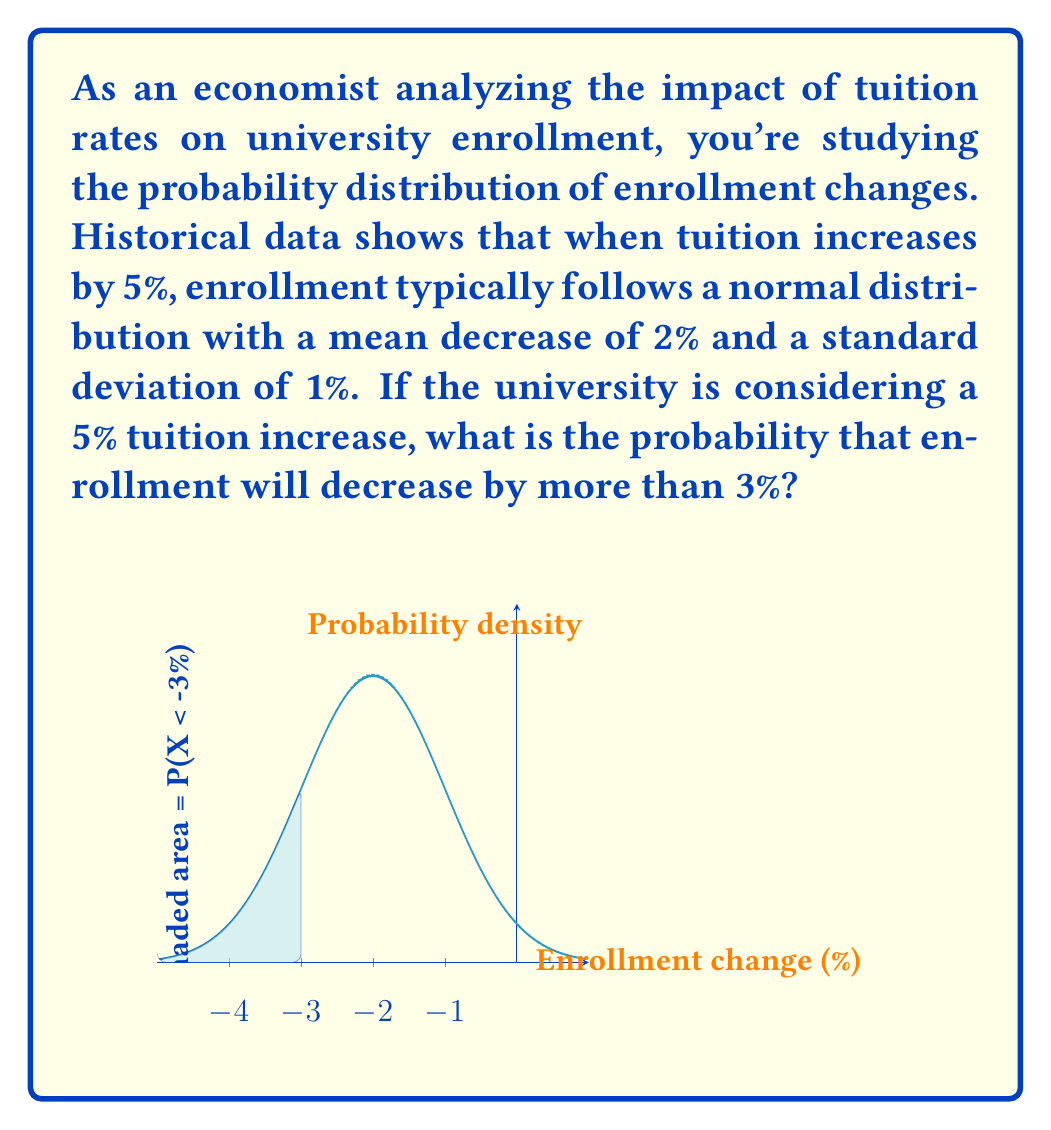What is the answer to this math problem? Let's approach this step-by-step:

1) We're dealing with a normal distribution where:
   $\mu = -2\%$ (mean decrease in enrollment)
   $\sigma = 1\%$ (standard deviation)

2) We want to find $P(X < -3\%)$, where $X$ is the enrollment change.

3) To use the standard normal distribution, we need to standardize our value:
   $$z = \frac{x - \mu}{\sigma} = \frac{-3 - (-2)}{1} = -1$$

4) Now we need to find $P(Z < -1)$ using the standard normal distribution table.

5) From the table, we find that $P(Z < -1) \approx 0.1587$

6) Therefore, the probability that enrollment will decrease by more than 3% is approximately 0.1587 or 15.87%.

This means there's about a 15.87% chance that enrollment will decrease by more than 3% if tuition is increased by 5%.
Answer: $P(X < -3\%) \approx 0.1587$ or $15.87\%$ 